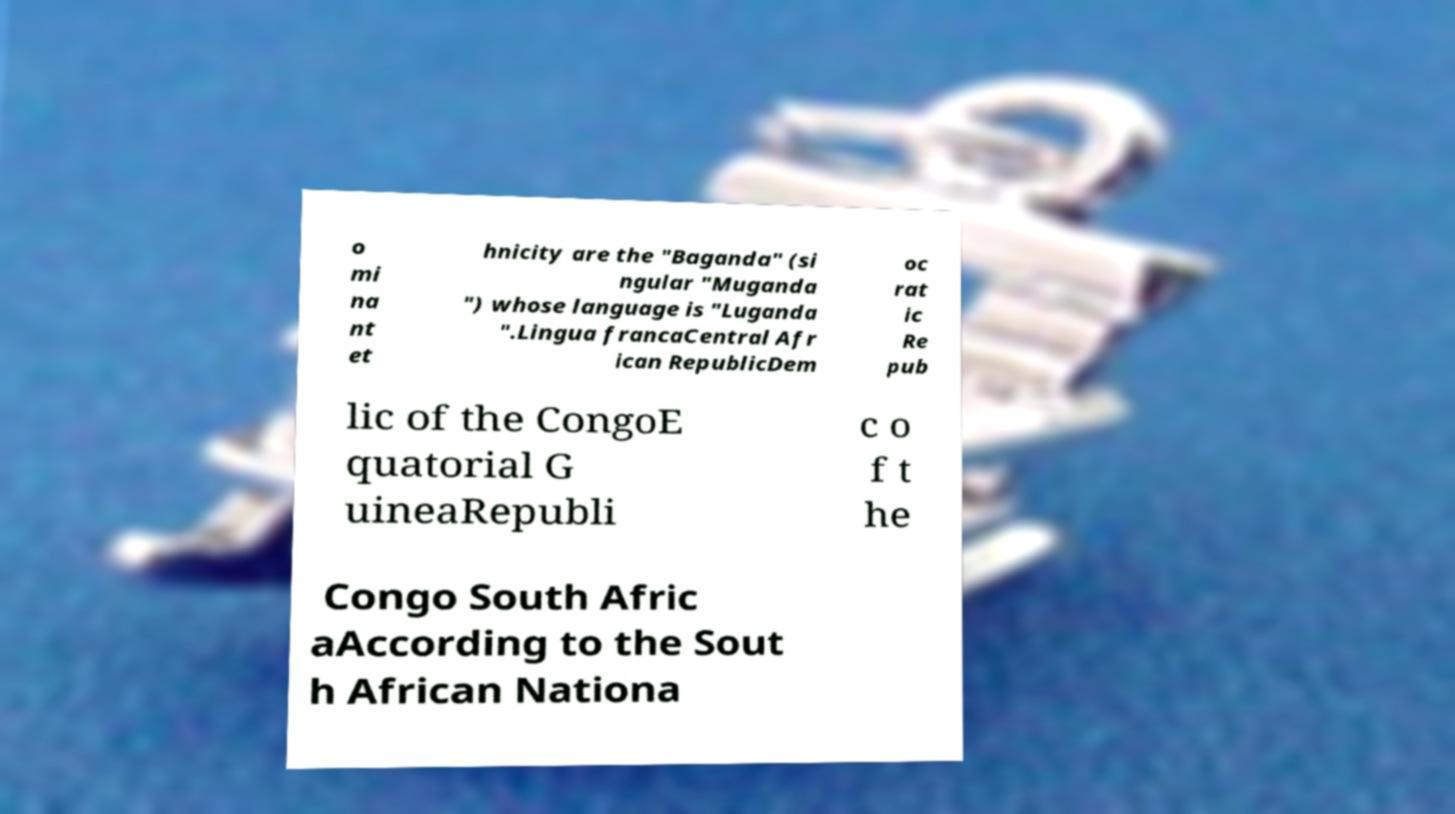What messages or text are displayed in this image? I need them in a readable, typed format. o mi na nt et hnicity are the "Baganda" (si ngular "Muganda ") whose language is "Luganda ".Lingua francaCentral Afr ican RepublicDem oc rat ic Re pub lic of the CongoE quatorial G uineaRepubli c o f t he Congo South Afric aAccording to the Sout h African Nationa 